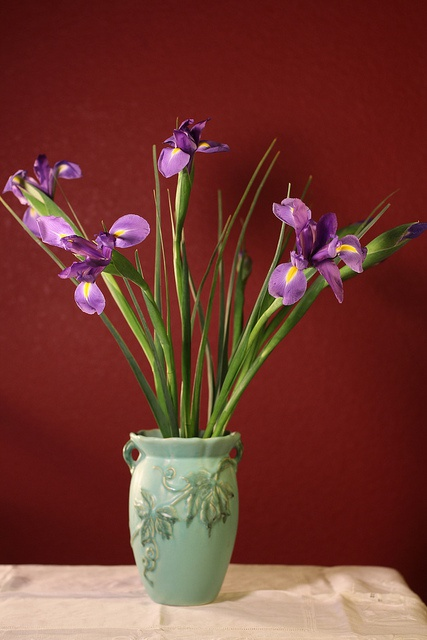Describe the objects in this image and their specific colors. I can see dining table in maroon, tan, and gray tones and vase in maroon, darkgray, olive, and gray tones in this image. 